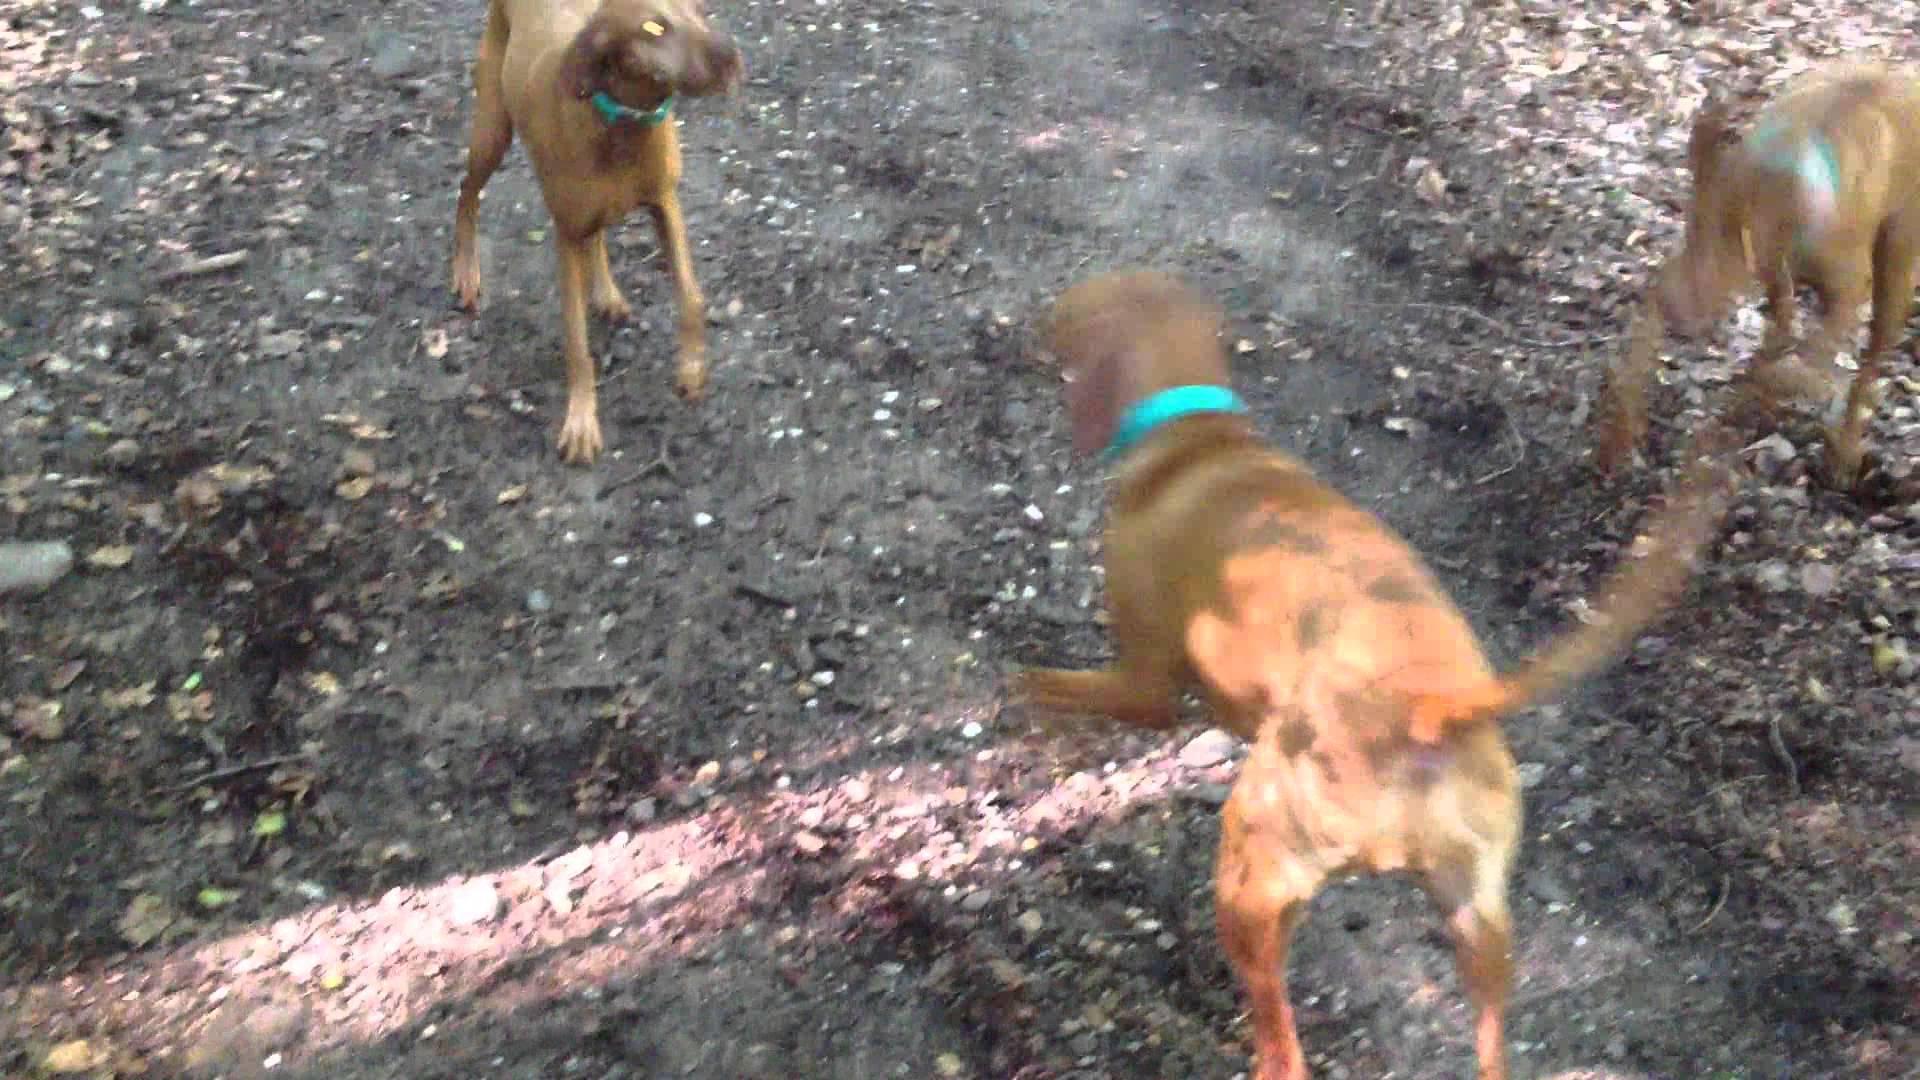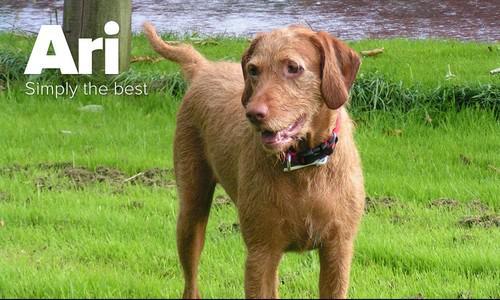The first image is the image on the left, the second image is the image on the right. For the images displayed, is the sentence "There are three dogs sitting." factually correct? Answer yes or no. No. The first image is the image on the left, the second image is the image on the right. For the images displayed, is the sentence "One dog is wearing an item on it's back and the rest are only wearing collars." factually correct? Answer yes or no. No. 